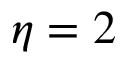<formula> <loc_0><loc_0><loc_500><loc_500>\eta = 2</formula> 